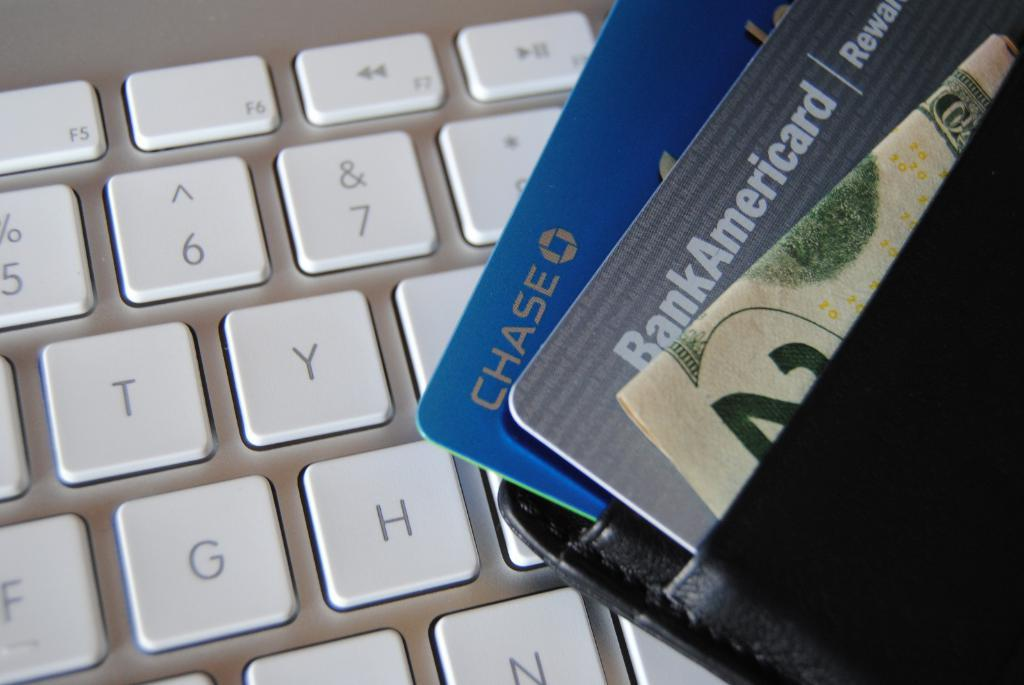<image>
Create a compact narrative representing the image presented. A Chase credit card, a Rewards card and a 20 dollar bill rest on a white keyboard. 